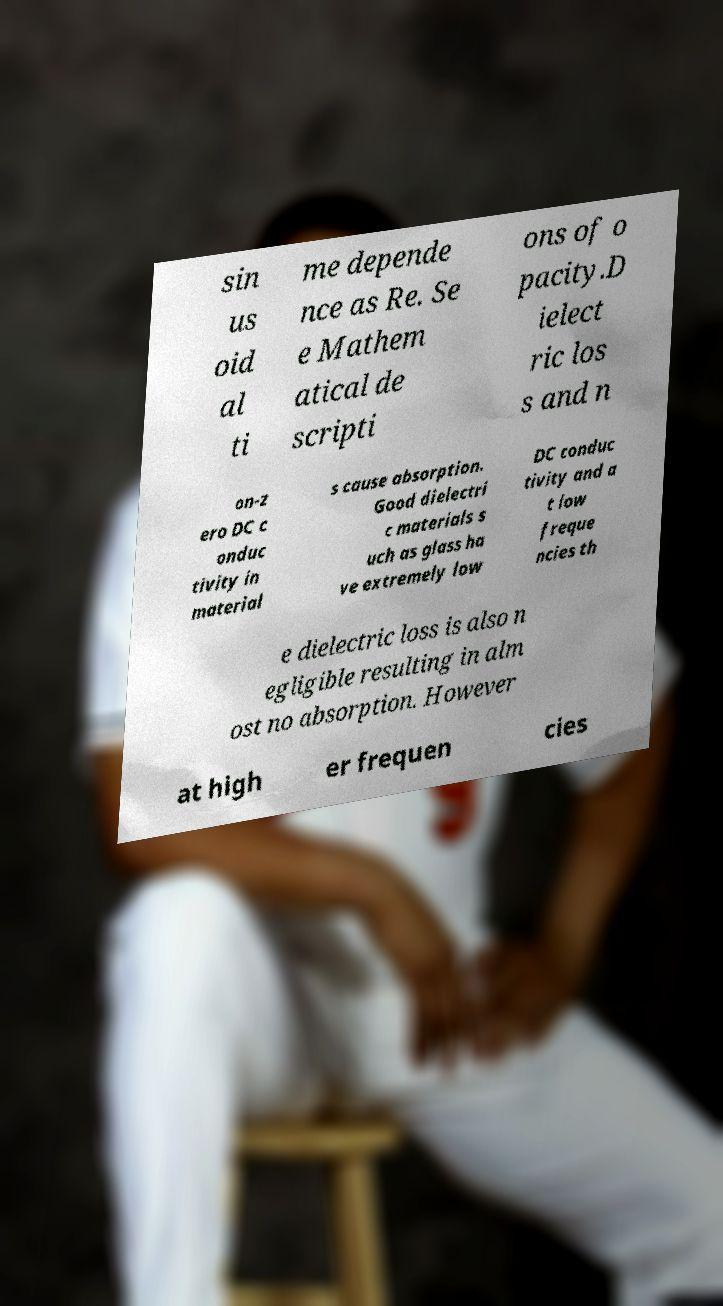For documentation purposes, I need the text within this image transcribed. Could you provide that? sin us oid al ti me depende nce as Re. Se e Mathem atical de scripti ons of o pacity.D ielect ric los s and n on-z ero DC c onduc tivity in material s cause absorption. Good dielectri c materials s uch as glass ha ve extremely low DC conduc tivity and a t low freque ncies th e dielectric loss is also n egligible resulting in alm ost no absorption. However at high er frequen cies 